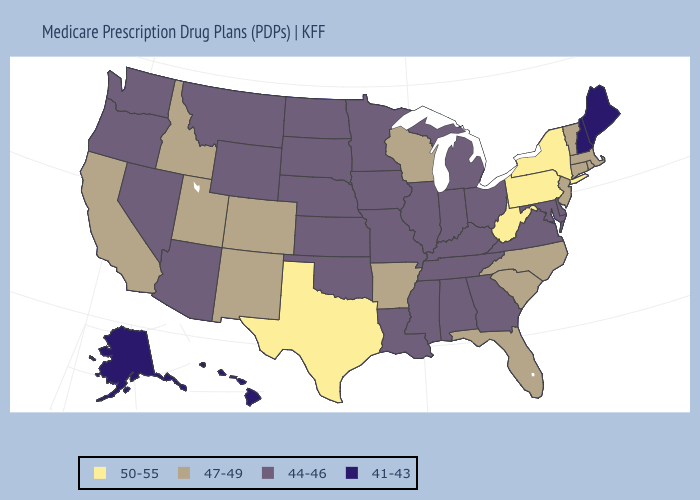Name the states that have a value in the range 44-46?
Answer briefly. Alabama, Arizona, Delaware, Georgia, Iowa, Illinois, Indiana, Kansas, Kentucky, Louisiana, Maryland, Michigan, Minnesota, Missouri, Mississippi, Montana, North Dakota, Nebraska, Nevada, Ohio, Oklahoma, Oregon, South Dakota, Tennessee, Virginia, Washington, Wyoming. Does Wisconsin have a lower value than Texas?
Write a very short answer. Yes. What is the highest value in the USA?
Write a very short answer. 50-55. Which states have the lowest value in the USA?
Quick response, please. Alaska, Hawaii, Maine, New Hampshire. Does Nevada have a lower value than Delaware?
Concise answer only. No. Which states have the highest value in the USA?
Write a very short answer. New York, Pennsylvania, Texas, West Virginia. What is the value of Indiana?
Write a very short answer. 44-46. Does Washington have a higher value than Wisconsin?
Answer briefly. No. Does Michigan have the lowest value in the USA?
Give a very brief answer. No. What is the highest value in the USA?
Quick response, please. 50-55. What is the highest value in the South ?
Quick response, please. 50-55. Among the states that border Georgia , which have the highest value?
Concise answer only. Florida, North Carolina, South Carolina. What is the value of Kentucky?
Keep it brief. 44-46. Does New York have the same value as Texas?
Write a very short answer. Yes. 